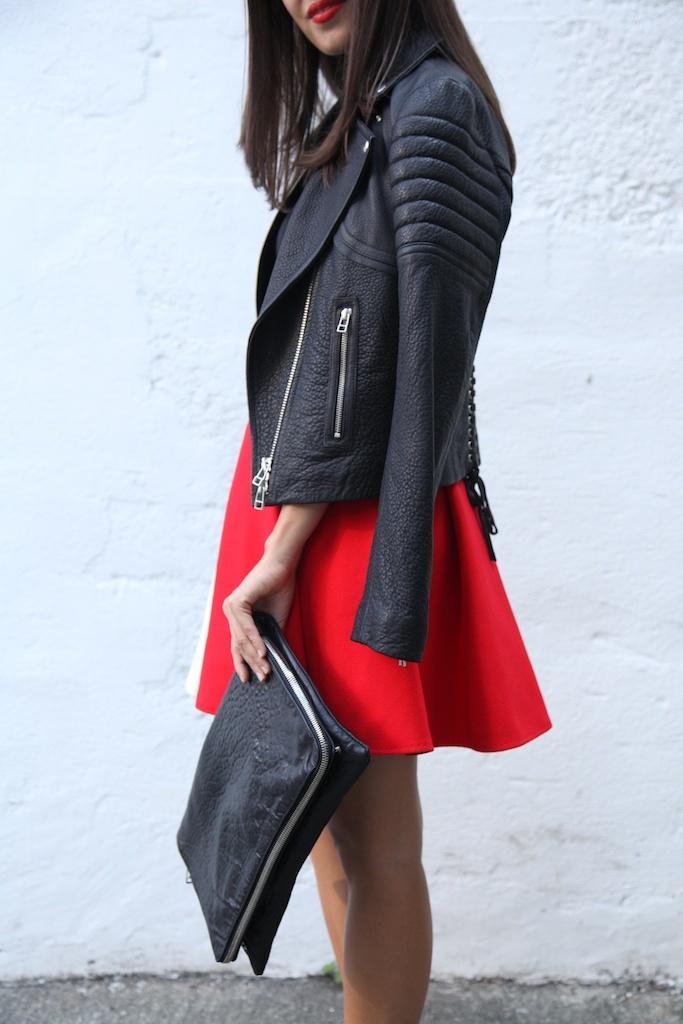How would you summarize this image in a sentence or two? In this picture we can see a girl in the black jacket is standing on the path and holding an object. Behind the woman there is a white wall. 